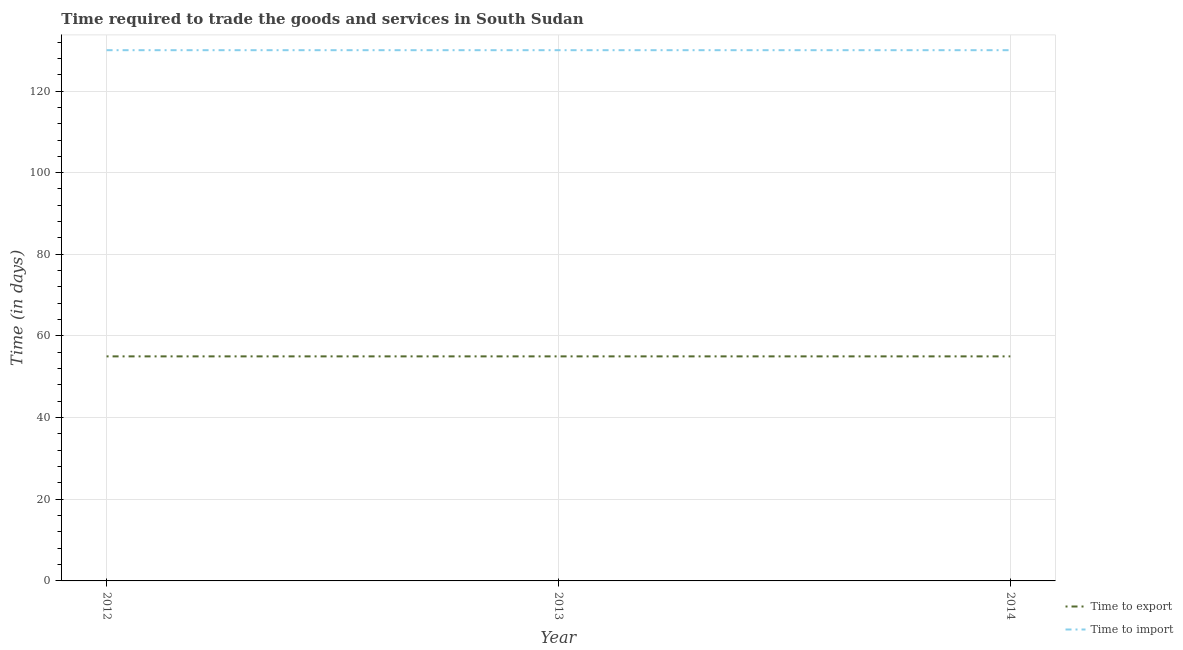What is the time to import in 2013?
Give a very brief answer. 130. Across all years, what is the maximum time to export?
Provide a short and direct response. 55. Across all years, what is the minimum time to export?
Make the answer very short. 55. In which year was the time to export minimum?
Provide a succinct answer. 2012. What is the total time to import in the graph?
Make the answer very short. 390. What is the difference between the time to import in 2012 and that in 2014?
Provide a short and direct response. 0. What is the difference between the time to export in 2013 and the time to import in 2012?
Provide a succinct answer. -75. What is the average time to import per year?
Make the answer very short. 130. In the year 2014, what is the difference between the time to import and time to export?
Make the answer very short. 75. In how many years, is the time to import greater than 44 days?
Ensure brevity in your answer.  3. What is the ratio of the time to import in 2013 to that in 2014?
Make the answer very short. 1. What is the difference between the highest and the second highest time to import?
Make the answer very short. 0. What is the difference between the highest and the lowest time to export?
Provide a succinct answer. 0. Does the time to export monotonically increase over the years?
Provide a short and direct response. No. How many lines are there?
Give a very brief answer. 2. Are the values on the major ticks of Y-axis written in scientific E-notation?
Offer a very short reply. No. Where does the legend appear in the graph?
Provide a short and direct response. Bottom right. How many legend labels are there?
Keep it short and to the point. 2. How are the legend labels stacked?
Make the answer very short. Vertical. What is the title of the graph?
Make the answer very short. Time required to trade the goods and services in South Sudan. Does "% of gross capital formation" appear as one of the legend labels in the graph?
Ensure brevity in your answer.  No. What is the label or title of the X-axis?
Your answer should be compact. Year. What is the label or title of the Y-axis?
Give a very brief answer. Time (in days). What is the Time (in days) of Time to import in 2012?
Offer a very short reply. 130. What is the Time (in days) in Time to export in 2013?
Offer a very short reply. 55. What is the Time (in days) of Time to import in 2013?
Give a very brief answer. 130. What is the Time (in days) of Time to export in 2014?
Ensure brevity in your answer.  55. What is the Time (in days) in Time to import in 2014?
Your answer should be compact. 130. Across all years, what is the maximum Time (in days) in Time to import?
Keep it short and to the point. 130. Across all years, what is the minimum Time (in days) of Time to import?
Your answer should be very brief. 130. What is the total Time (in days) of Time to export in the graph?
Your answer should be compact. 165. What is the total Time (in days) in Time to import in the graph?
Your answer should be compact. 390. What is the difference between the Time (in days) in Time to import in 2012 and that in 2014?
Provide a short and direct response. 0. What is the difference between the Time (in days) of Time to export in 2013 and that in 2014?
Offer a terse response. 0. What is the difference between the Time (in days) in Time to export in 2012 and the Time (in days) in Time to import in 2013?
Offer a terse response. -75. What is the difference between the Time (in days) of Time to export in 2012 and the Time (in days) of Time to import in 2014?
Your answer should be very brief. -75. What is the difference between the Time (in days) in Time to export in 2013 and the Time (in days) in Time to import in 2014?
Your answer should be very brief. -75. What is the average Time (in days) in Time to export per year?
Provide a succinct answer. 55. What is the average Time (in days) in Time to import per year?
Give a very brief answer. 130. In the year 2012, what is the difference between the Time (in days) of Time to export and Time (in days) of Time to import?
Offer a very short reply. -75. In the year 2013, what is the difference between the Time (in days) in Time to export and Time (in days) in Time to import?
Provide a succinct answer. -75. In the year 2014, what is the difference between the Time (in days) of Time to export and Time (in days) of Time to import?
Give a very brief answer. -75. What is the ratio of the Time (in days) of Time to export in 2012 to that in 2013?
Ensure brevity in your answer.  1. What is the ratio of the Time (in days) in Time to import in 2012 to that in 2013?
Provide a succinct answer. 1. What is the ratio of the Time (in days) in Time to export in 2013 to that in 2014?
Provide a short and direct response. 1. What is the ratio of the Time (in days) in Time to import in 2013 to that in 2014?
Keep it short and to the point. 1. What is the difference between the highest and the lowest Time (in days) in Time to export?
Provide a short and direct response. 0. What is the difference between the highest and the lowest Time (in days) in Time to import?
Your answer should be very brief. 0. 